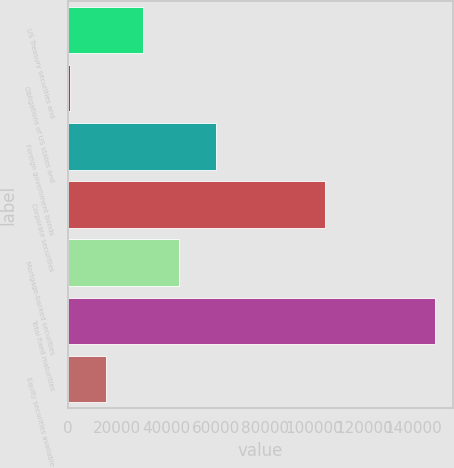Convert chart. <chart><loc_0><loc_0><loc_500><loc_500><bar_chart><fcel>US Treasury securities and<fcel>Obligations of US states and<fcel>Foreign government bonds<fcel>Corporate securities<fcel>Mortgage-backed securities<fcel>Total fixed maturities<fcel>Equity securities available<nl><fcel>30510.8<fcel>962<fcel>60059.6<fcel>104303<fcel>45285.2<fcel>148706<fcel>15736.4<nl></chart> 